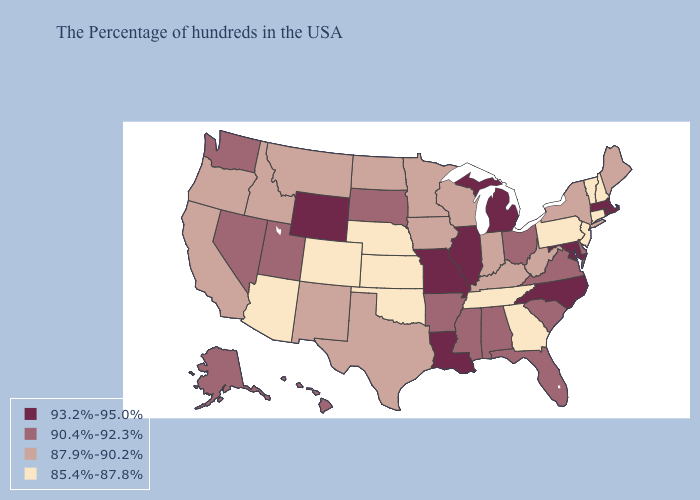Which states have the highest value in the USA?
Answer briefly. Massachusetts, Rhode Island, Maryland, North Carolina, Michigan, Illinois, Louisiana, Missouri, Wyoming. What is the highest value in states that border Wyoming?
Be succinct. 90.4%-92.3%. What is the value of North Dakota?
Concise answer only. 87.9%-90.2%. Does Wyoming have the highest value in the West?
Keep it brief. Yes. Among the states that border Alabama , which have the highest value?
Concise answer only. Florida, Mississippi. Name the states that have a value in the range 87.9%-90.2%?
Give a very brief answer. Maine, New York, West Virginia, Kentucky, Indiana, Wisconsin, Minnesota, Iowa, Texas, North Dakota, New Mexico, Montana, Idaho, California, Oregon. Name the states that have a value in the range 85.4%-87.8%?
Give a very brief answer. New Hampshire, Vermont, Connecticut, New Jersey, Pennsylvania, Georgia, Tennessee, Kansas, Nebraska, Oklahoma, Colorado, Arizona. Which states have the highest value in the USA?
Be succinct. Massachusetts, Rhode Island, Maryland, North Carolina, Michigan, Illinois, Louisiana, Missouri, Wyoming. Name the states that have a value in the range 90.4%-92.3%?
Write a very short answer. Delaware, Virginia, South Carolina, Ohio, Florida, Alabama, Mississippi, Arkansas, South Dakota, Utah, Nevada, Washington, Alaska, Hawaii. What is the value of Oregon?
Keep it brief. 87.9%-90.2%. Name the states that have a value in the range 93.2%-95.0%?
Quick response, please. Massachusetts, Rhode Island, Maryland, North Carolina, Michigan, Illinois, Louisiana, Missouri, Wyoming. Among the states that border West Virginia , does Maryland have the lowest value?
Concise answer only. No. What is the lowest value in the USA?
Keep it brief. 85.4%-87.8%. Does the first symbol in the legend represent the smallest category?
Short answer required. No. 